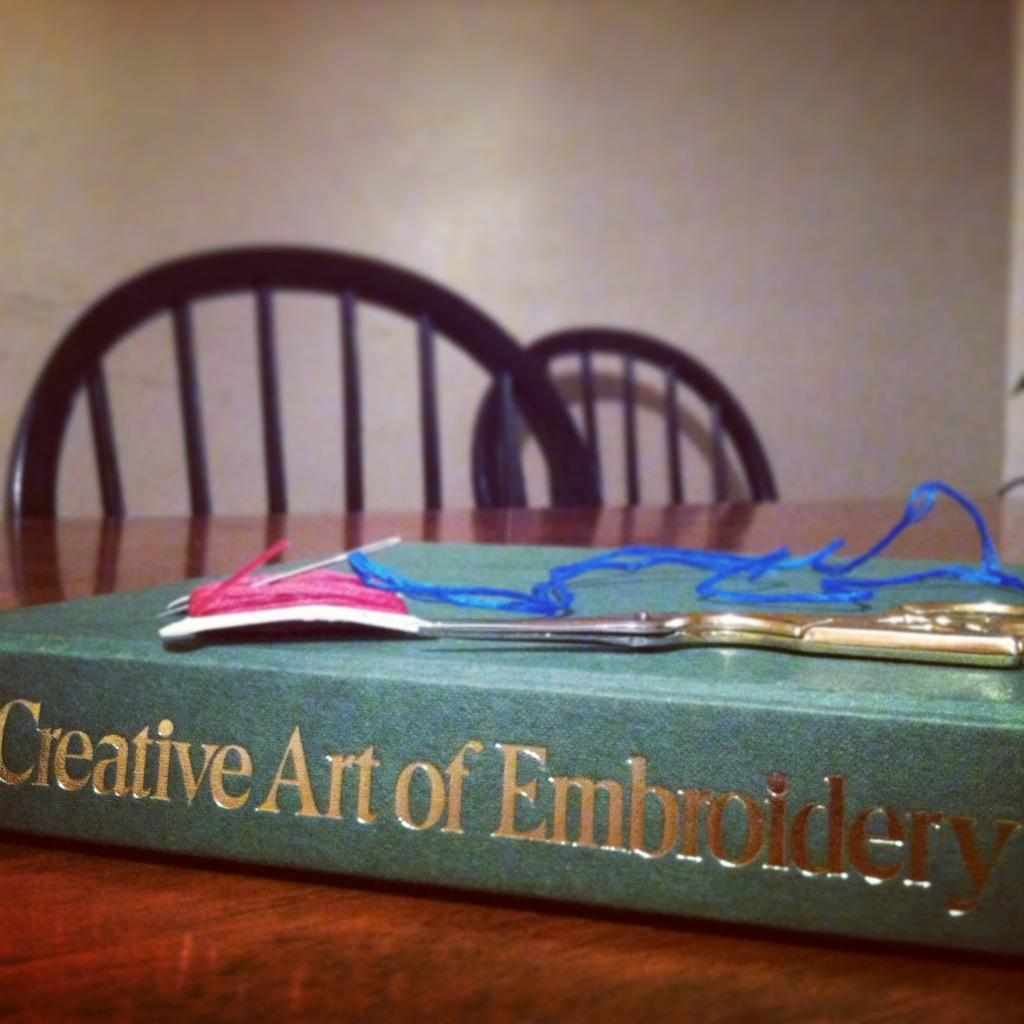<image>
Give a short and clear explanation of the subsequent image. A green book with the title Creative Art of Embroidery 